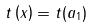<formula> <loc_0><loc_0><loc_500><loc_500>\, t \left ( x \right ) = t ( a _ { 1 } )</formula> 